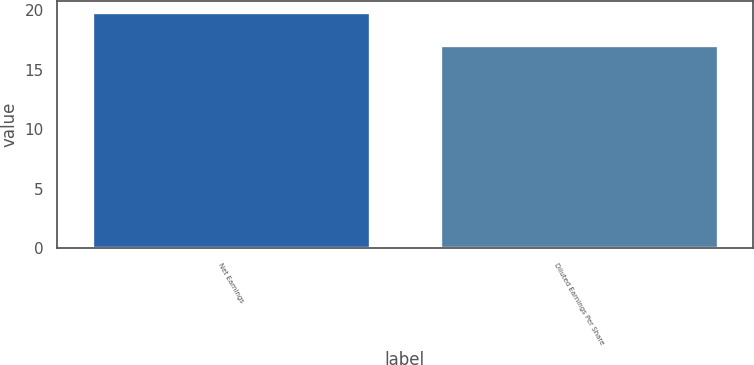Convert chart. <chart><loc_0><loc_0><loc_500><loc_500><bar_chart><fcel>Net Earnings<fcel>Diluted Earnings Per Share<nl><fcel>19.8<fcel>17.1<nl></chart> 